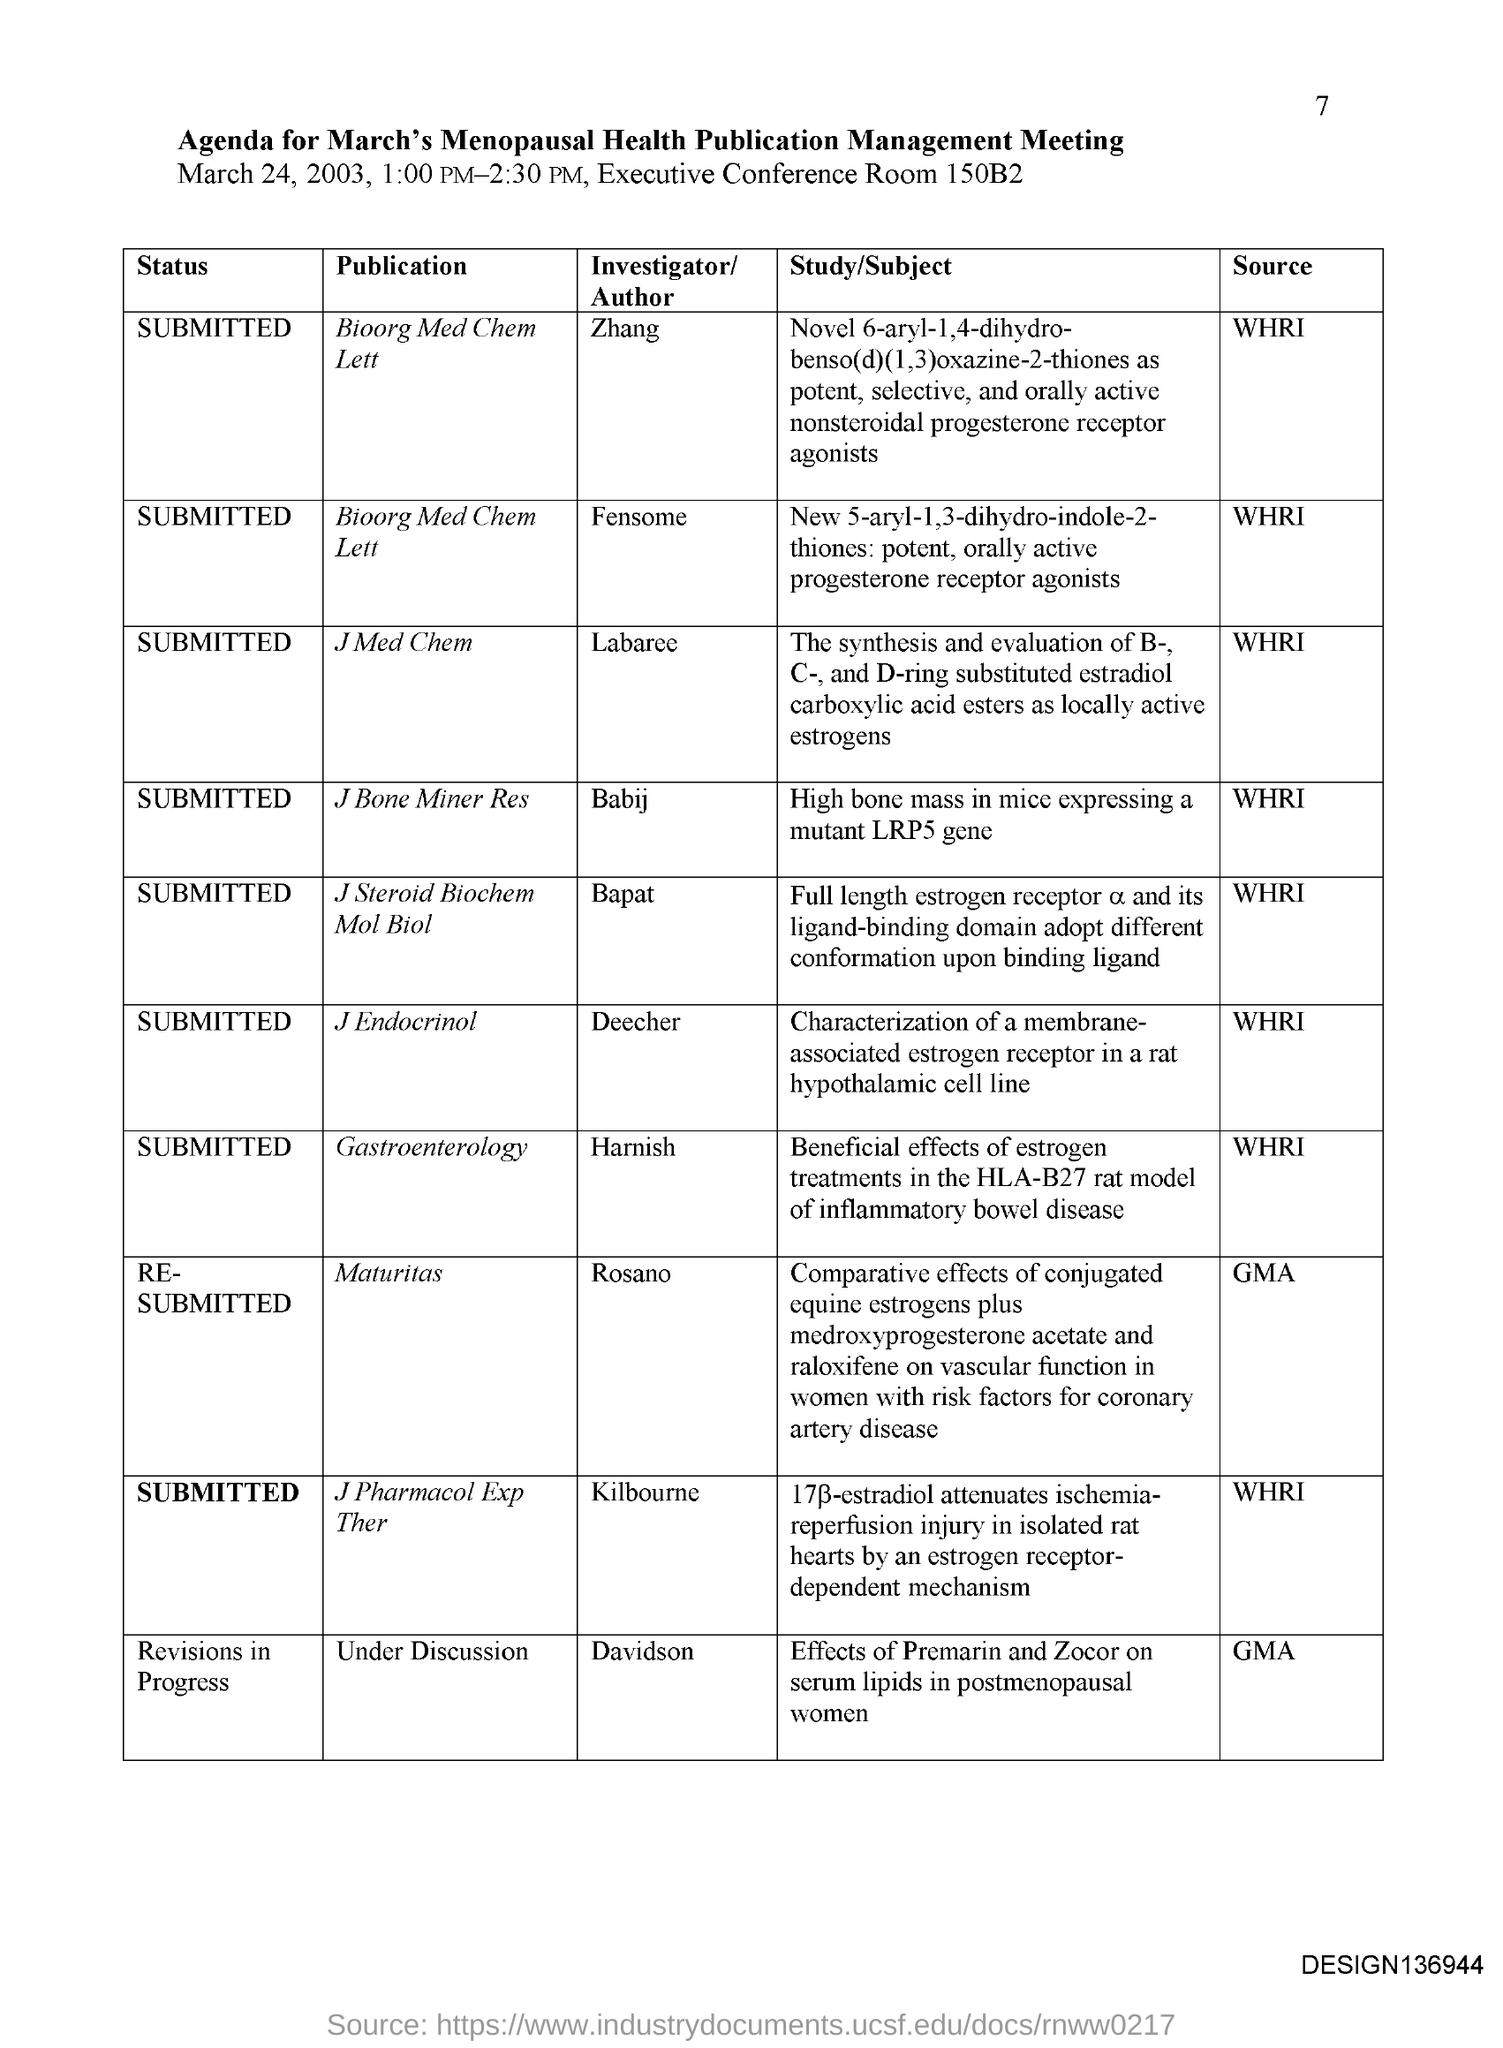Point out several critical features in this image. The meeting will take place in the Executive Conference Room 150B2. The investigator responsible for the publication 'J Bone Miner Res' is Babij. The investigator for the publication "J Med Chem" is Labaree. The investigator for the publication "Journal of Endocrinology" is Deecher. The investigator for the publication "J Steroid Biochem Mol Biol" is Bapat. 